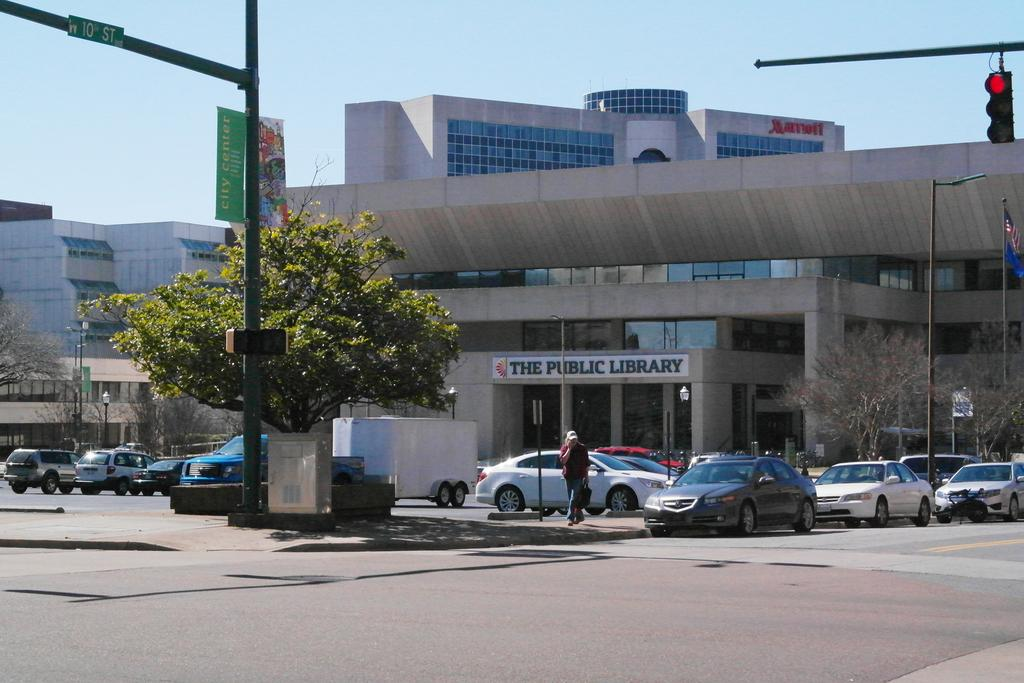What types of vehicles can be seen in the image? There are vehicles in the image, but the specific types are not mentioned. What are the people in the image doing? People are walking on the ground in the image. What can be seen in the background of the image? There are trees, buildings, pole lights, the sky, and traffic lights in the background of the image. Are there any other objects visible in the background of the image? Yes, there are other unspecified objects in the background of the image. What theory is being discussed by the people walking on the ground in the image? There is no indication in the image that the people are discussing any theory. Can you tell me what type of soda is being served at the event in the image? There is no event or soda present in the image. Is there a letter visible on the vehicles in the image? The specific types of vehicles are not mentioned, so it is impossible to determine if any of them have letters on them. 